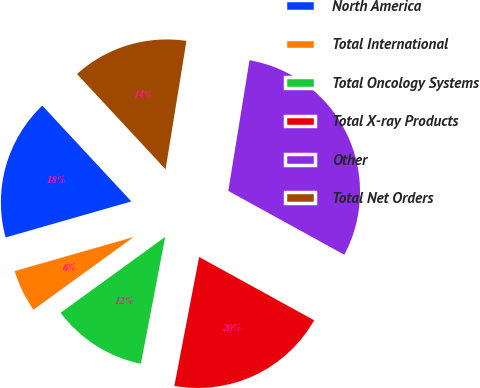<chart> <loc_0><loc_0><loc_500><loc_500><pie_chart><fcel>North America<fcel>Total International<fcel>Total Oncology Systems<fcel>Total X-ray Products<fcel>Other<fcel>Total Net Orders<nl><fcel>17.53%<fcel>5.54%<fcel>11.99%<fcel>20.02%<fcel>30.44%<fcel>14.48%<nl></chart> 